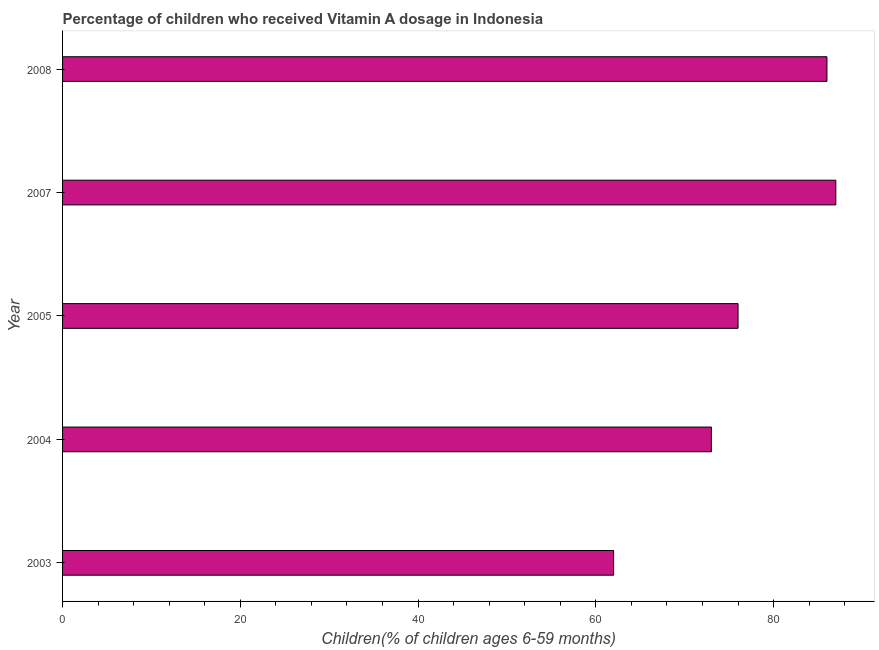Does the graph contain any zero values?
Give a very brief answer. No. What is the title of the graph?
Provide a succinct answer. Percentage of children who received Vitamin A dosage in Indonesia. What is the label or title of the X-axis?
Your answer should be compact. Children(% of children ages 6-59 months). What is the label or title of the Y-axis?
Make the answer very short. Year. What is the vitamin a supplementation coverage rate in 2008?
Ensure brevity in your answer.  86. Across all years, what is the minimum vitamin a supplementation coverage rate?
Provide a succinct answer. 62. In which year was the vitamin a supplementation coverage rate minimum?
Your response must be concise. 2003. What is the sum of the vitamin a supplementation coverage rate?
Your response must be concise. 384. What is the average vitamin a supplementation coverage rate per year?
Provide a short and direct response. 76.8. What is the median vitamin a supplementation coverage rate?
Provide a succinct answer. 76. What is the ratio of the vitamin a supplementation coverage rate in 2005 to that in 2008?
Ensure brevity in your answer.  0.88. Is the vitamin a supplementation coverage rate in 2004 less than that in 2008?
Offer a terse response. Yes. What is the difference between the highest and the lowest vitamin a supplementation coverage rate?
Give a very brief answer. 25. In how many years, is the vitamin a supplementation coverage rate greater than the average vitamin a supplementation coverage rate taken over all years?
Provide a succinct answer. 2. How many bars are there?
Provide a succinct answer. 5. Are all the bars in the graph horizontal?
Your answer should be compact. Yes. How many years are there in the graph?
Make the answer very short. 5. What is the difference between two consecutive major ticks on the X-axis?
Make the answer very short. 20. Are the values on the major ticks of X-axis written in scientific E-notation?
Offer a terse response. No. What is the Children(% of children ages 6-59 months) in 2008?
Provide a short and direct response. 86. What is the difference between the Children(% of children ages 6-59 months) in 2003 and 2004?
Give a very brief answer. -11. What is the difference between the Children(% of children ages 6-59 months) in 2003 and 2005?
Keep it short and to the point. -14. What is the difference between the Children(% of children ages 6-59 months) in 2003 and 2007?
Offer a terse response. -25. What is the difference between the Children(% of children ages 6-59 months) in 2003 and 2008?
Give a very brief answer. -24. What is the difference between the Children(% of children ages 6-59 months) in 2004 and 2008?
Provide a succinct answer. -13. What is the difference between the Children(% of children ages 6-59 months) in 2005 and 2008?
Provide a succinct answer. -10. What is the difference between the Children(% of children ages 6-59 months) in 2007 and 2008?
Provide a short and direct response. 1. What is the ratio of the Children(% of children ages 6-59 months) in 2003 to that in 2004?
Your response must be concise. 0.85. What is the ratio of the Children(% of children ages 6-59 months) in 2003 to that in 2005?
Offer a very short reply. 0.82. What is the ratio of the Children(% of children ages 6-59 months) in 2003 to that in 2007?
Offer a terse response. 0.71. What is the ratio of the Children(% of children ages 6-59 months) in 2003 to that in 2008?
Keep it short and to the point. 0.72. What is the ratio of the Children(% of children ages 6-59 months) in 2004 to that in 2007?
Your answer should be very brief. 0.84. What is the ratio of the Children(% of children ages 6-59 months) in 2004 to that in 2008?
Provide a short and direct response. 0.85. What is the ratio of the Children(% of children ages 6-59 months) in 2005 to that in 2007?
Keep it short and to the point. 0.87. What is the ratio of the Children(% of children ages 6-59 months) in 2005 to that in 2008?
Provide a succinct answer. 0.88. 